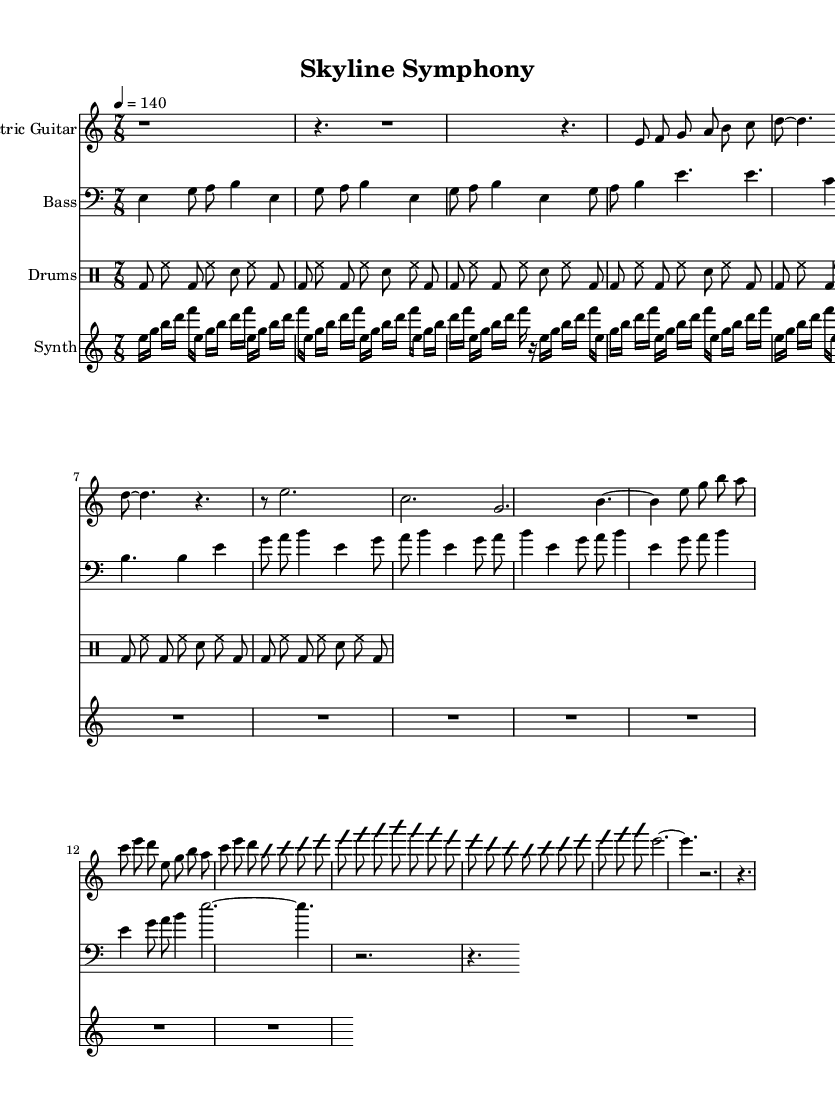What is the time signature of the piece? The time signature is located at the beginning of the score. It is indicated as 7/8, which shows that there are seven beats in each measure and the eighth note gets the beat.
Answer: 7/8 What is the tempo marking for the music? The tempo marking is specified in beats per minute at the beginning of the score. It indicates that the piece should be played at a speed of 140 beats per minute.
Answer: 140 Which instrument plays the main riff in the verse? The main riff is labeled in the section for the Electric Guitar under the 'Main Riff (Verse)'. This indicates that the Electric Guitar is responsible for playing this part.
Answer: Electric Guitar How many times is the Main Riff repeated? The score shows the section "Main Riff (Verse)" with the instruction "\repeat unfold 2" which indicates that this riff is repeated two times.
Answer: 2 What is the key signature of this music? The key signature can be found at the start of the score, which shows that the music is in E Phrygian. This means that the scale used primarily consists of the notes that belong to the E Phrygian mode.
Answer: E Phrygian What type of drum pattern is used in the main section? The drum part labeled as "Main pattern" describes a repeating sequence under the drums, which consists of bass drum, hi-hat, and snare with a specific order. This pattern is typical in metal music, depicting a strong backbeat.
Answer: Repetitive bass and snare pattern What is notable about the structure of the song in terms of Metal influence? The structure exhibits varied time signatures, complex rhythms, and improvisational sections that are characteristic of Progressive Metal. This is indicated through the complex riffs and the bridge section of the Electric Guitar which adds a unique dynamic to the composition.
Answer: Complex rhythms and structures 